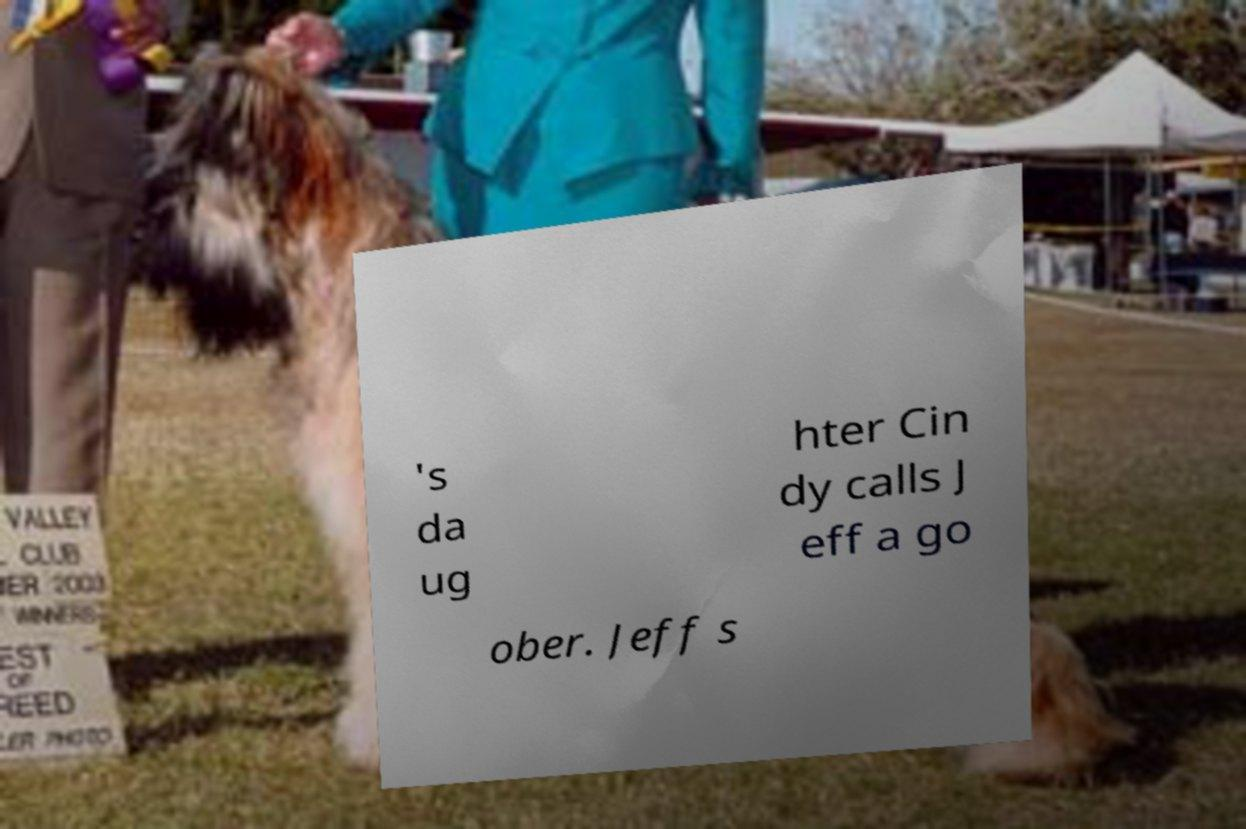Please identify and transcribe the text found in this image. 's da ug hter Cin dy calls J eff a go ober. Jeff s 